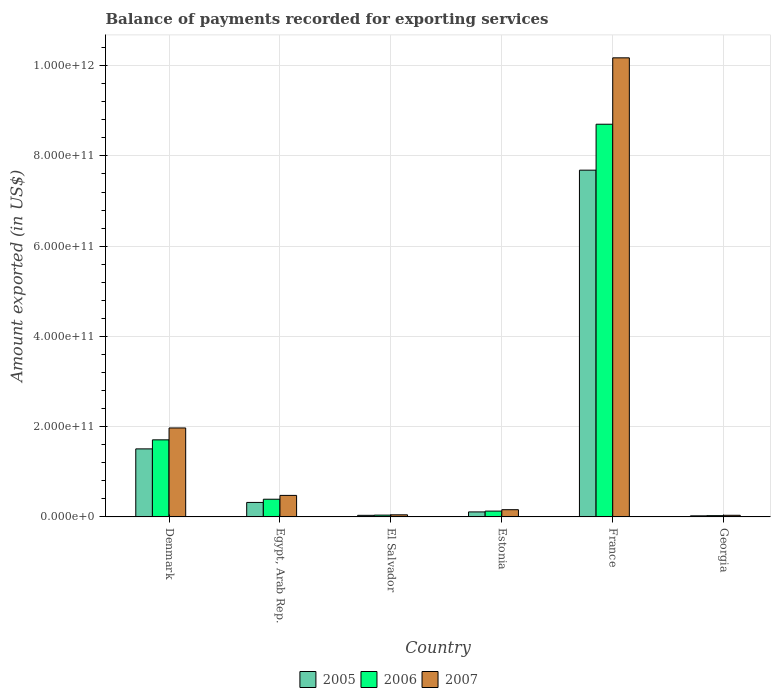How many different coloured bars are there?
Offer a very short reply. 3. How many groups of bars are there?
Give a very brief answer. 6. Are the number of bars per tick equal to the number of legend labels?
Ensure brevity in your answer.  Yes. Are the number of bars on each tick of the X-axis equal?
Your answer should be compact. Yes. How many bars are there on the 2nd tick from the right?
Your response must be concise. 3. What is the label of the 3rd group of bars from the left?
Your answer should be compact. El Salvador. What is the amount exported in 2005 in Georgia?
Offer a terse response. 2.42e+09. Across all countries, what is the maximum amount exported in 2005?
Your answer should be very brief. 7.68e+11. Across all countries, what is the minimum amount exported in 2006?
Ensure brevity in your answer.  2.84e+09. In which country was the amount exported in 2006 maximum?
Your answer should be compact. France. In which country was the amount exported in 2005 minimum?
Your response must be concise. Georgia. What is the total amount exported in 2005 in the graph?
Offer a terse response. 9.68e+11. What is the difference between the amount exported in 2006 in El Salvador and that in Estonia?
Your answer should be very brief. -8.92e+09. What is the difference between the amount exported in 2005 in Egypt, Arab Rep. and the amount exported in 2006 in Georgia?
Offer a very short reply. 2.93e+1. What is the average amount exported in 2006 per country?
Provide a succinct answer. 1.83e+11. What is the difference between the amount exported of/in 2007 and amount exported of/in 2006 in Estonia?
Make the answer very short. 3.12e+09. In how many countries, is the amount exported in 2005 greater than 520000000000 US$?
Your answer should be compact. 1. What is the ratio of the amount exported in 2007 in Egypt, Arab Rep. to that in Georgia?
Give a very brief answer. 13.09. What is the difference between the highest and the second highest amount exported in 2007?
Your answer should be compact. 8.20e+11. What is the difference between the highest and the lowest amount exported in 2006?
Offer a terse response. 8.67e+11. What does the 1st bar from the left in El Salvador represents?
Your response must be concise. 2005. What does the 3rd bar from the right in Estonia represents?
Provide a short and direct response. 2005. How many bars are there?
Offer a very short reply. 18. How many countries are there in the graph?
Ensure brevity in your answer.  6. What is the difference between two consecutive major ticks on the Y-axis?
Offer a terse response. 2.00e+11. Does the graph contain grids?
Keep it short and to the point. Yes. How many legend labels are there?
Ensure brevity in your answer.  3. How are the legend labels stacked?
Ensure brevity in your answer.  Horizontal. What is the title of the graph?
Make the answer very short. Balance of payments recorded for exporting services. Does "1986" appear as one of the legend labels in the graph?
Provide a succinct answer. No. What is the label or title of the X-axis?
Offer a terse response. Country. What is the label or title of the Y-axis?
Keep it short and to the point. Amount exported (in US$). What is the Amount exported (in US$) in 2005 in Denmark?
Give a very brief answer. 1.51e+11. What is the Amount exported (in US$) in 2006 in Denmark?
Your response must be concise. 1.71e+11. What is the Amount exported (in US$) in 2007 in Denmark?
Provide a succinct answer. 1.97e+11. What is the Amount exported (in US$) of 2005 in Egypt, Arab Rep.?
Provide a succinct answer. 3.21e+1. What is the Amount exported (in US$) of 2006 in Egypt, Arab Rep.?
Provide a short and direct response. 3.92e+1. What is the Amount exported (in US$) in 2007 in Egypt, Arab Rep.?
Make the answer very short. 4.77e+1. What is the Amount exported (in US$) in 2005 in El Salvador?
Your answer should be compact. 3.52e+09. What is the Amount exported (in US$) of 2006 in El Salvador?
Provide a short and direct response. 4.01e+09. What is the Amount exported (in US$) of 2007 in El Salvador?
Offer a terse response. 4.66e+09. What is the Amount exported (in US$) of 2005 in Estonia?
Give a very brief answer. 1.11e+1. What is the Amount exported (in US$) of 2006 in Estonia?
Your answer should be compact. 1.29e+1. What is the Amount exported (in US$) in 2007 in Estonia?
Keep it short and to the point. 1.60e+1. What is the Amount exported (in US$) in 2005 in France?
Your response must be concise. 7.68e+11. What is the Amount exported (in US$) of 2006 in France?
Provide a short and direct response. 8.70e+11. What is the Amount exported (in US$) of 2007 in France?
Keep it short and to the point. 1.02e+12. What is the Amount exported (in US$) of 2005 in Georgia?
Offer a terse response. 2.42e+09. What is the Amount exported (in US$) in 2006 in Georgia?
Your answer should be compact. 2.84e+09. What is the Amount exported (in US$) of 2007 in Georgia?
Your response must be concise. 3.65e+09. Across all countries, what is the maximum Amount exported (in US$) of 2005?
Your response must be concise. 7.68e+11. Across all countries, what is the maximum Amount exported (in US$) in 2006?
Provide a short and direct response. 8.70e+11. Across all countries, what is the maximum Amount exported (in US$) in 2007?
Your answer should be very brief. 1.02e+12. Across all countries, what is the minimum Amount exported (in US$) of 2005?
Make the answer very short. 2.42e+09. Across all countries, what is the minimum Amount exported (in US$) in 2006?
Your answer should be very brief. 2.84e+09. Across all countries, what is the minimum Amount exported (in US$) in 2007?
Provide a short and direct response. 3.65e+09. What is the total Amount exported (in US$) of 2005 in the graph?
Give a very brief answer. 9.68e+11. What is the total Amount exported (in US$) in 2006 in the graph?
Keep it short and to the point. 1.10e+12. What is the total Amount exported (in US$) in 2007 in the graph?
Give a very brief answer. 1.29e+12. What is the difference between the Amount exported (in US$) in 2005 in Denmark and that in Egypt, Arab Rep.?
Offer a very short reply. 1.19e+11. What is the difference between the Amount exported (in US$) in 2006 in Denmark and that in Egypt, Arab Rep.?
Give a very brief answer. 1.32e+11. What is the difference between the Amount exported (in US$) in 2007 in Denmark and that in Egypt, Arab Rep.?
Your answer should be very brief. 1.49e+11. What is the difference between the Amount exported (in US$) in 2005 in Denmark and that in El Salvador?
Offer a very short reply. 1.47e+11. What is the difference between the Amount exported (in US$) of 2006 in Denmark and that in El Salvador?
Provide a succinct answer. 1.67e+11. What is the difference between the Amount exported (in US$) of 2007 in Denmark and that in El Salvador?
Your answer should be very brief. 1.93e+11. What is the difference between the Amount exported (in US$) of 2005 in Denmark and that in Estonia?
Make the answer very short. 1.40e+11. What is the difference between the Amount exported (in US$) of 2006 in Denmark and that in Estonia?
Provide a short and direct response. 1.58e+11. What is the difference between the Amount exported (in US$) in 2007 in Denmark and that in Estonia?
Your answer should be compact. 1.81e+11. What is the difference between the Amount exported (in US$) of 2005 in Denmark and that in France?
Ensure brevity in your answer.  -6.18e+11. What is the difference between the Amount exported (in US$) in 2006 in Denmark and that in France?
Make the answer very short. -6.99e+11. What is the difference between the Amount exported (in US$) of 2007 in Denmark and that in France?
Your answer should be very brief. -8.20e+11. What is the difference between the Amount exported (in US$) in 2005 in Denmark and that in Georgia?
Offer a very short reply. 1.48e+11. What is the difference between the Amount exported (in US$) of 2006 in Denmark and that in Georgia?
Keep it short and to the point. 1.68e+11. What is the difference between the Amount exported (in US$) in 2007 in Denmark and that in Georgia?
Your answer should be very brief. 1.94e+11. What is the difference between the Amount exported (in US$) in 2005 in Egypt, Arab Rep. and that in El Salvador?
Offer a very short reply. 2.86e+1. What is the difference between the Amount exported (in US$) in 2006 in Egypt, Arab Rep. and that in El Salvador?
Keep it short and to the point. 3.52e+1. What is the difference between the Amount exported (in US$) in 2007 in Egypt, Arab Rep. and that in El Salvador?
Your response must be concise. 4.30e+1. What is the difference between the Amount exported (in US$) of 2005 in Egypt, Arab Rep. and that in Estonia?
Your answer should be very brief. 2.10e+1. What is the difference between the Amount exported (in US$) in 2006 in Egypt, Arab Rep. and that in Estonia?
Your response must be concise. 2.63e+1. What is the difference between the Amount exported (in US$) in 2007 in Egypt, Arab Rep. and that in Estonia?
Offer a very short reply. 3.17e+1. What is the difference between the Amount exported (in US$) of 2005 in Egypt, Arab Rep. and that in France?
Make the answer very short. -7.36e+11. What is the difference between the Amount exported (in US$) of 2006 in Egypt, Arab Rep. and that in France?
Make the answer very short. -8.31e+11. What is the difference between the Amount exported (in US$) of 2007 in Egypt, Arab Rep. and that in France?
Your answer should be very brief. -9.70e+11. What is the difference between the Amount exported (in US$) in 2005 in Egypt, Arab Rep. and that in Georgia?
Ensure brevity in your answer.  2.97e+1. What is the difference between the Amount exported (in US$) of 2006 in Egypt, Arab Rep. and that in Georgia?
Offer a terse response. 3.64e+1. What is the difference between the Amount exported (in US$) of 2007 in Egypt, Arab Rep. and that in Georgia?
Provide a short and direct response. 4.41e+1. What is the difference between the Amount exported (in US$) of 2005 in El Salvador and that in Estonia?
Offer a very short reply. -7.58e+09. What is the difference between the Amount exported (in US$) of 2006 in El Salvador and that in Estonia?
Ensure brevity in your answer.  -8.92e+09. What is the difference between the Amount exported (in US$) of 2007 in El Salvador and that in Estonia?
Provide a succinct answer. -1.14e+1. What is the difference between the Amount exported (in US$) of 2005 in El Salvador and that in France?
Provide a short and direct response. -7.65e+11. What is the difference between the Amount exported (in US$) in 2006 in El Salvador and that in France?
Your answer should be compact. -8.66e+11. What is the difference between the Amount exported (in US$) in 2007 in El Salvador and that in France?
Your answer should be very brief. -1.01e+12. What is the difference between the Amount exported (in US$) in 2005 in El Salvador and that in Georgia?
Make the answer very short. 1.10e+09. What is the difference between the Amount exported (in US$) of 2006 in El Salvador and that in Georgia?
Provide a short and direct response. 1.16e+09. What is the difference between the Amount exported (in US$) in 2007 in El Salvador and that in Georgia?
Offer a terse response. 1.01e+09. What is the difference between the Amount exported (in US$) in 2005 in Estonia and that in France?
Offer a terse response. -7.57e+11. What is the difference between the Amount exported (in US$) in 2006 in Estonia and that in France?
Keep it short and to the point. -8.57e+11. What is the difference between the Amount exported (in US$) in 2007 in Estonia and that in France?
Provide a short and direct response. -1.00e+12. What is the difference between the Amount exported (in US$) in 2005 in Estonia and that in Georgia?
Offer a terse response. 8.69e+09. What is the difference between the Amount exported (in US$) of 2006 in Estonia and that in Georgia?
Provide a short and direct response. 1.01e+1. What is the difference between the Amount exported (in US$) of 2007 in Estonia and that in Georgia?
Offer a terse response. 1.24e+1. What is the difference between the Amount exported (in US$) in 2005 in France and that in Georgia?
Your answer should be compact. 7.66e+11. What is the difference between the Amount exported (in US$) in 2006 in France and that in Georgia?
Provide a succinct answer. 8.67e+11. What is the difference between the Amount exported (in US$) of 2007 in France and that in Georgia?
Provide a short and direct response. 1.01e+12. What is the difference between the Amount exported (in US$) in 2005 in Denmark and the Amount exported (in US$) in 2006 in Egypt, Arab Rep.?
Ensure brevity in your answer.  1.12e+11. What is the difference between the Amount exported (in US$) of 2005 in Denmark and the Amount exported (in US$) of 2007 in Egypt, Arab Rep.?
Give a very brief answer. 1.03e+11. What is the difference between the Amount exported (in US$) of 2006 in Denmark and the Amount exported (in US$) of 2007 in Egypt, Arab Rep.?
Offer a very short reply. 1.23e+11. What is the difference between the Amount exported (in US$) of 2005 in Denmark and the Amount exported (in US$) of 2006 in El Salvador?
Keep it short and to the point. 1.47e+11. What is the difference between the Amount exported (in US$) of 2005 in Denmark and the Amount exported (in US$) of 2007 in El Salvador?
Your response must be concise. 1.46e+11. What is the difference between the Amount exported (in US$) in 2006 in Denmark and the Amount exported (in US$) in 2007 in El Salvador?
Make the answer very short. 1.66e+11. What is the difference between the Amount exported (in US$) of 2005 in Denmark and the Amount exported (in US$) of 2006 in Estonia?
Provide a short and direct response. 1.38e+11. What is the difference between the Amount exported (in US$) of 2005 in Denmark and the Amount exported (in US$) of 2007 in Estonia?
Ensure brevity in your answer.  1.35e+11. What is the difference between the Amount exported (in US$) of 2006 in Denmark and the Amount exported (in US$) of 2007 in Estonia?
Provide a succinct answer. 1.55e+11. What is the difference between the Amount exported (in US$) in 2005 in Denmark and the Amount exported (in US$) in 2006 in France?
Offer a terse response. -7.19e+11. What is the difference between the Amount exported (in US$) of 2005 in Denmark and the Amount exported (in US$) of 2007 in France?
Offer a very short reply. -8.67e+11. What is the difference between the Amount exported (in US$) of 2006 in Denmark and the Amount exported (in US$) of 2007 in France?
Your response must be concise. -8.47e+11. What is the difference between the Amount exported (in US$) of 2005 in Denmark and the Amount exported (in US$) of 2006 in Georgia?
Offer a terse response. 1.48e+11. What is the difference between the Amount exported (in US$) in 2005 in Denmark and the Amount exported (in US$) in 2007 in Georgia?
Your answer should be compact. 1.47e+11. What is the difference between the Amount exported (in US$) of 2006 in Denmark and the Amount exported (in US$) of 2007 in Georgia?
Give a very brief answer. 1.67e+11. What is the difference between the Amount exported (in US$) in 2005 in Egypt, Arab Rep. and the Amount exported (in US$) in 2006 in El Salvador?
Provide a short and direct response. 2.81e+1. What is the difference between the Amount exported (in US$) of 2005 in Egypt, Arab Rep. and the Amount exported (in US$) of 2007 in El Salvador?
Your answer should be compact. 2.75e+1. What is the difference between the Amount exported (in US$) of 2006 in Egypt, Arab Rep. and the Amount exported (in US$) of 2007 in El Salvador?
Your response must be concise. 3.46e+1. What is the difference between the Amount exported (in US$) of 2005 in Egypt, Arab Rep. and the Amount exported (in US$) of 2006 in Estonia?
Give a very brief answer. 1.92e+1. What is the difference between the Amount exported (in US$) of 2005 in Egypt, Arab Rep. and the Amount exported (in US$) of 2007 in Estonia?
Offer a very short reply. 1.61e+1. What is the difference between the Amount exported (in US$) of 2006 in Egypt, Arab Rep. and the Amount exported (in US$) of 2007 in Estonia?
Provide a succinct answer. 2.32e+1. What is the difference between the Amount exported (in US$) of 2005 in Egypt, Arab Rep. and the Amount exported (in US$) of 2006 in France?
Provide a succinct answer. -8.38e+11. What is the difference between the Amount exported (in US$) in 2005 in Egypt, Arab Rep. and the Amount exported (in US$) in 2007 in France?
Ensure brevity in your answer.  -9.85e+11. What is the difference between the Amount exported (in US$) of 2006 in Egypt, Arab Rep. and the Amount exported (in US$) of 2007 in France?
Your response must be concise. -9.78e+11. What is the difference between the Amount exported (in US$) in 2005 in Egypt, Arab Rep. and the Amount exported (in US$) in 2006 in Georgia?
Offer a very short reply. 2.93e+1. What is the difference between the Amount exported (in US$) of 2005 in Egypt, Arab Rep. and the Amount exported (in US$) of 2007 in Georgia?
Offer a terse response. 2.85e+1. What is the difference between the Amount exported (in US$) of 2006 in Egypt, Arab Rep. and the Amount exported (in US$) of 2007 in Georgia?
Your answer should be compact. 3.56e+1. What is the difference between the Amount exported (in US$) in 2005 in El Salvador and the Amount exported (in US$) in 2006 in Estonia?
Your answer should be compact. -9.41e+09. What is the difference between the Amount exported (in US$) of 2005 in El Salvador and the Amount exported (in US$) of 2007 in Estonia?
Provide a succinct answer. -1.25e+1. What is the difference between the Amount exported (in US$) in 2006 in El Salvador and the Amount exported (in US$) in 2007 in Estonia?
Your response must be concise. -1.20e+1. What is the difference between the Amount exported (in US$) in 2005 in El Salvador and the Amount exported (in US$) in 2006 in France?
Your answer should be compact. -8.67e+11. What is the difference between the Amount exported (in US$) in 2005 in El Salvador and the Amount exported (in US$) in 2007 in France?
Ensure brevity in your answer.  -1.01e+12. What is the difference between the Amount exported (in US$) of 2006 in El Salvador and the Amount exported (in US$) of 2007 in France?
Your response must be concise. -1.01e+12. What is the difference between the Amount exported (in US$) of 2005 in El Salvador and the Amount exported (in US$) of 2006 in Georgia?
Ensure brevity in your answer.  6.76e+08. What is the difference between the Amount exported (in US$) of 2005 in El Salvador and the Amount exported (in US$) of 2007 in Georgia?
Your answer should be compact. -1.28e+08. What is the difference between the Amount exported (in US$) in 2006 in El Salvador and the Amount exported (in US$) in 2007 in Georgia?
Your answer should be compact. 3.60e+08. What is the difference between the Amount exported (in US$) in 2005 in Estonia and the Amount exported (in US$) in 2006 in France?
Your answer should be very brief. -8.59e+11. What is the difference between the Amount exported (in US$) in 2005 in Estonia and the Amount exported (in US$) in 2007 in France?
Ensure brevity in your answer.  -1.01e+12. What is the difference between the Amount exported (in US$) of 2006 in Estonia and the Amount exported (in US$) of 2007 in France?
Offer a very short reply. -1.00e+12. What is the difference between the Amount exported (in US$) of 2005 in Estonia and the Amount exported (in US$) of 2006 in Georgia?
Offer a terse response. 8.26e+09. What is the difference between the Amount exported (in US$) of 2005 in Estonia and the Amount exported (in US$) of 2007 in Georgia?
Offer a terse response. 7.46e+09. What is the difference between the Amount exported (in US$) of 2006 in Estonia and the Amount exported (in US$) of 2007 in Georgia?
Offer a very short reply. 9.28e+09. What is the difference between the Amount exported (in US$) in 2005 in France and the Amount exported (in US$) in 2006 in Georgia?
Offer a very short reply. 7.66e+11. What is the difference between the Amount exported (in US$) of 2005 in France and the Amount exported (in US$) of 2007 in Georgia?
Keep it short and to the point. 7.65e+11. What is the difference between the Amount exported (in US$) of 2006 in France and the Amount exported (in US$) of 2007 in Georgia?
Provide a short and direct response. 8.67e+11. What is the average Amount exported (in US$) of 2005 per country?
Offer a terse response. 1.61e+11. What is the average Amount exported (in US$) in 2006 per country?
Offer a very short reply. 1.83e+11. What is the average Amount exported (in US$) in 2007 per country?
Your response must be concise. 2.14e+11. What is the difference between the Amount exported (in US$) in 2005 and Amount exported (in US$) in 2006 in Denmark?
Your answer should be very brief. -2.00e+1. What is the difference between the Amount exported (in US$) in 2005 and Amount exported (in US$) in 2007 in Denmark?
Keep it short and to the point. -4.64e+1. What is the difference between the Amount exported (in US$) of 2006 and Amount exported (in US$) of 2007 in Denmark?
Your answer should be very brief. -2.64e+1. What is the difference between the Amount exported (in US$) of 2005 and Amount exported (in US$) of 2006 in Egypt, Arab Rep.?
Make the answer very short. -7.10e+09. What is the difference between the Amount exported (in US$) in 2005 and Amount exported (in US$) in 2007 in Egypt, Arab Rep.?
Your response must be concise. -1.56e+1. What is the difference between the Amount exported (in US$) in 2006 and Amount exported (in US$) in 2007 in Egypt, Arab Rep.?
Offer a very short reply. -8.47e+09. What is the difference between the Amount exported (in US$) of 2005 and Amount exported (in US$) of 2006 in El Salvador?
Make the answer very short. -4.88e+08. What is the difference between the Amount exported (in US$) in 2005 and Amount exported (in US$) in 2007 in El Salvador?
Give a very brief answer. -1.14e+09. What is the difference between the Amount exported (in US$) of 2006 and Amount exported (in US$) of 2007 in El Salvador?
Your answer should be compact. -6.52e+08. What is the difference between the Amount exported (in US$) in 2005 and Amount exported (in US$) in 2006 in Estonia?
Provide a succinct answer. -1.82e+09. What is the difference between the Amount exported (in US$) in 2005 and Amount exported (in US$) in 2007 in Estonia?
Keep it short and to the point. -4.94e+09. What is the difference between the Amount exported (in US$) of 2006 and Amount exported (in US$) of 2007 in Estonia?
Your answer should be very brief. -3.12e+09. What is the difference between the Amount exported (in US$) in 2005 and Amount exported (in US$) in 2006 in France?
Give a very brief answer. -1.02e+11. What is the difference between the Amount exported (in US$) of 2005 and Amount exported (in US$) of 2007 in France?
Your answer should be very brief. -2.49e+11. What is the difference between the Amount exported (in US$) of 2006 and Amount exported (in US$) of 2007 in France?
Provide a succinct answer. -1.47e+11. What is the difference between the Amount exported (in US$) of 2005 and Amount exported (in US$) of 2006 in Georgia?
Ensure brevity in your answer.  -4.26e+08. What is the difference between the Amount exported (in US$) in 2005 and Amount exported (in US$) in 2007 in Georgia?
Give a very brief answer. -1.23e+09. What is the difference between the Amount exported (in US$) of 2006 and Amount exported (in US$) of 2007 in Georgia?
Give a very brief answer. -8.04e+08. What is the ratio of the Amount exported (in US$) in 2005 in Denmark to that in Egypt, Arab Rep.?
Your answer should be very brief. 4.69. What is the ratio of the Amount exported (in US$) in 2006 in Denmark to that in Egypt, Arab Rep.?
Your answer should be very brief. 4.35. What is the ratio of the Amount exported (in US$) in 2007 in Denmark to that in Egypt, Arab Rep.?
Provide a succinct answer. 4.13. What is the ratio of the Amount exported (in US$) of 2005 in Denmark to that in El Salvador?
Keep it short and to the point. 42.88. What is the ratio of the Amount exported (in US$) of 2006 in Denmark to that in El Salvador?
Give a very brief answer. 42.65. What is the ratio of the Amount exported (in US$) of 2007 in Denmark to that in El Salvador?
Give a very brief answer. 42.33. What is the ratio of the Amount exported (in US$) of 2005 in Denmark to that in Estonia?
Your response must be concise. 13.58. What is the ratio of the Amount exported (in US$) in 2006 in Denmark to that in Estonia?
Your response must be concise. 13.22. What is the ratio of the Amount exported (in US$) of 2007 in Denmark to that in Estonia?
Ensure brevity in your answer.  12.29. What is the ratio of the Amount exported (in US$) in 2005 in Denmark to that in France?
Your answer should be very brief. 0.2. What is the ratio of the Amount exported (in US$) of 2006 in Denmark to that in France?
Provide a succinct answer. 0.2. What is the ratio of the Amount exported (in US$) in 2007 in Denmark to that in France?
Offer a very short reply. 0.19. What is the ratio of the Amount exported (in US$) in 2005 in Denmark to that in Georgia?
Ensure brevity in your answer.  62.43. What is the ratio of the Amount exported (in US$) in 2006 in Denmark to that in Georgia?
Ensure brevity in your answer.  60.12. What is the ratio of the Amount exported (in US$) of 2007 in Denmark to that in Georgia?
Your response must be concise. 54.09. What is the ratio of the Amount exported (in US$) of 2005 in Egypt, Arab Rep. to that in El Salvador?
Offer a very short reply. 9.14. What is the ratio of the Amount exported (in US$) of 2006 in Egypt, Arab Rep. to that in El Salvador?
Your answer should be compact. 9.8. What is the ratio of the Amount exported (in US$) of 2007 in Egypt, Arab Rep. to that in El Salvador?
Your answer should be compact. 10.24. What is the ratio of the Amount exported (in US$) in 2005 in Egypt, Arab Rep. to that in Estonia?
Keep it short and to the point. 2.9. What is the ratio of the Amount exported (in US$) in 2006 in Egypt, Arab Rep. to that in Estonia?
Make the answer very short. 3.04. What is the ratio of the Amount exported (in US$) in 2007 in Egypt, Arab Rep. to that in Estonia?
Your answer should be compact. 2.97. What is the ratio of the Amount exported (in US$) in 2005 in Egypt, Arab Rep. to that in France?
Make the answer very short. 0.04. What is the ratio of the Amount exported (in US$) of 2006 in Egypt, Arab Rep. to that in France?
Offer a terse response. 0.05. What is the ratio of the Amount exported (in US$) of 2007 in Egypt, Arab Rep. to that in France?
Keep it short and to the point. 0.05. What is the ratio of the Amount exported (in US$) of 2005 in Egypt, Arab Rep. to that in Georgia?
Give a very brief answer. 13.31. What is the ratio of the Amount exported (in US$) of 2006 in Egypt, Arab Rep. to that in Georgia?
Give a very brief answer. 13.81. What is the ratio of the Amount exported (in US$) of 2007 in Egypt, Arab Rep. to that in Georgia?
Provide a short and direct response. 13.09. What is the ratio of the Amount exported (in US$) of 2005 in El Salvador to that in Estonia?
Your answer should be compact. 0.32. What is the ratio of the Amount exported (in US$) in 2006 in El Salvador to that in Estonia?
Your answer should be very brief. 0.31. What is the ratio of the Amount exported (in US$) of 2007 in El Salvador to that in Estonia?
Keep it short and to the point. 0.29. What is the ratio of the Amount exported (in US$) of 2005 in El Salvador to that in France?
Your answer should be very brief. 0. What is the ratio of the Amount exported (in US$) of 2006 in El Salvador to that in France?
Make the answer very short. 0. What is the ratio of the Amount exported (in US$) of 2007 in El Salvador to that in France?
Make the answer very short. 0. What is the ratio of the Amount exported (in US$) in 2005 in El Salvador to that in Georgia?
Your answer should be very brief. 1.46. What is the ratio of the Amount exported (in US$) of 2006 in El Salvador to that in Georgia?
Ensure brevity in your answer.  1.41. What is the ratio of the Amount exported (in US$) of 2007 in El Salvador to that in Georgia?
Provide a succinct answer. 1.28. What is the ratio of the Amount exported (in US$) of 2005 in Estonia to that in France?
Provide a short and direct response. 0.01. What is the ratio of the Amount exported (in US$) in 2006 in Estonia to that in France?
Offer a terse response. 0.01. What is the ratio of the Amount exported (in US$) of 2007 in Estonia to that in France?
Provide a succinct answer. 0.02. What is the ratio of the Amount exported (in US$) in 2005 in Estonia to that in Georgia?
Provide a short and direct response. 4.6. What is the ratio of the Amount exported (in US$) in 2006 in Estonia to that in Georgia?
Offer a terse response. 4.55. What is the ratio of the Amount exported (in US$) of 2007 in Estonia to that in Georgia?
Your answer should be compact. 4.4. What is the ratio of the Amount exported (in US$) in 2005 in France to that in Georgia?
Ensure brevity in your answer.  318.18. What is the ratio of the Amount exported (in US$) of 2006 in France to that in Georgia?
Provide a succinct answer. 306.3. What is the ratio of the Amount exported (in US$) in 2007 in France to that in Georgia?
Keep it short and to the point. 279.1. What is the difference between the highest and the second highest Amount exported (in US$) of 2005?
Provide a short and direct response. 6.18e+11. What is the difference between the highest and the second highest Amount exported (in US$) of 2006?
Keep it short and to the point. 6.99e+11. What is the difference between the highest and the second highest Amount exported (in US$) of 2007?
Provide a short and direct response. 8.20e+11. What is the difference between the highest and the lowest Amount exported (in US$) of 2005?
Your answer should be compact. 7.66e+11. What is the difference between the highest and the lowest Amount exported (in US$) in 2006?
Your response must be concise. 8.67e+11. What is the difference between the highest and the lowest Amount exported (in US$) in 2007?
Ensure brevity in your answer.  1.01e+12. 